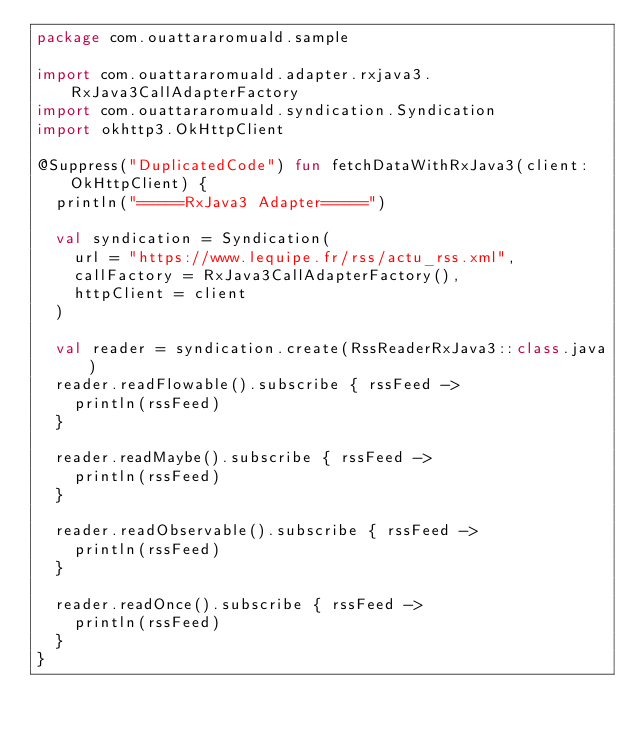Convert code to text. <code><loc_0><loc_0><loc_500><loc_500><_Kotlin_>package com.ouattararomuald.sample

import com.ouattararomuald.adapter.rxjava3.RxJava3CallAdapterFactory
import com.ouattararomuald.syndication.Syndication
import okhttp3.OkHttpClient

@Suppress("DuplicatedCode") fun fetchDataWithRxJava3(client: OkHttpClient) {
  println("=====RxJava3 Adapter=====")

  val syndication = Syndication(
    url = "https://www.lequipe.fr/rss/actu_rss.xml",
    callFactory = RxJava3CallAdapterFactory(),
    httpClient = client
  )

  val reader = syndication.create(RssReaderRxJava3::class.java)
  reader.readFlowable().subscribe { rssFeed ->
    println(rssFeed)
  }

  reader.readMaybe().subscribe { rssFeed ->
    println(rssFeed)
  }

  reader.readObservable().subscribe { rssFeed ->
    println(rssFeed)
  }

  reader.readOnce().subscribe { rssFeed ->
    println(rssFeed)
  }
}
</code> 